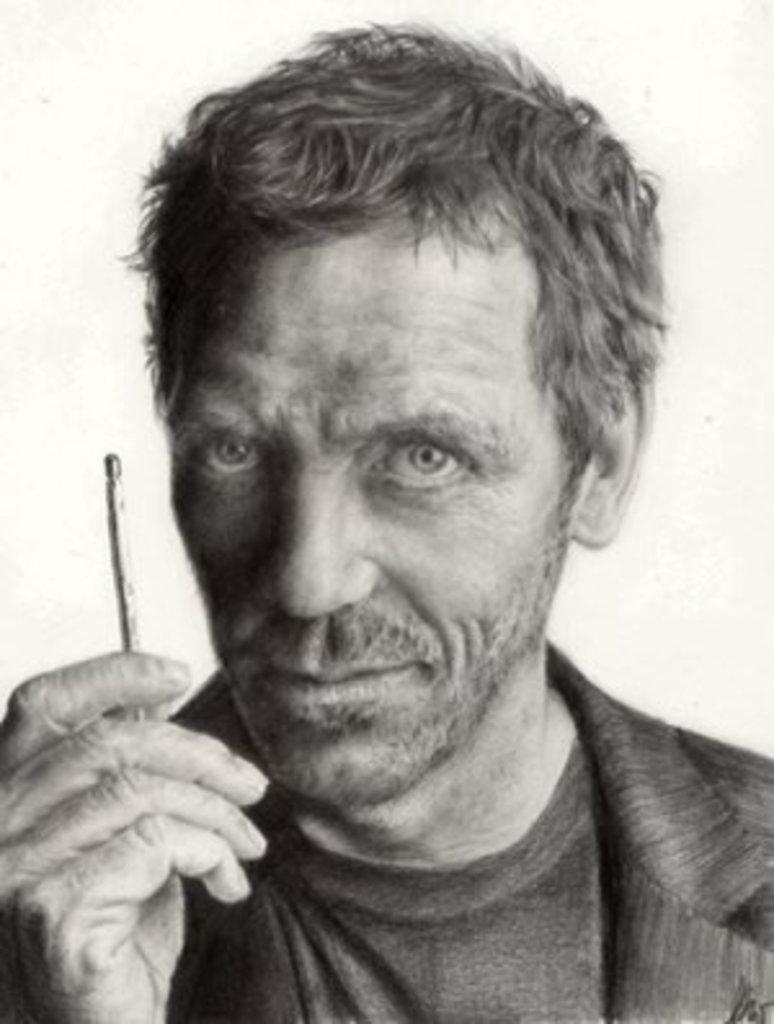What is the main subject of the image? The main subject of the image is a man. What is the man doing in the image? The man is holding an object with his hand. How many people are walking towards the end of the street in the image? There is no information about a street or people walking in the image; it only features a man holding an object. 